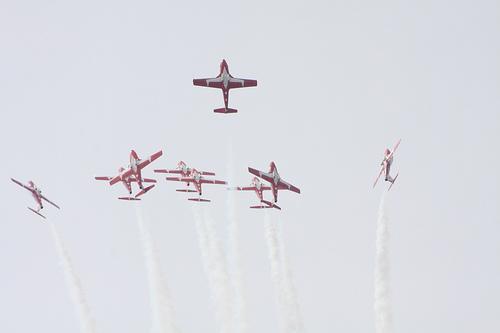How many planes have a trail of white behind them?
Give a very brief answer. 9. How many planes can you see?
Give a very brief answer. 9. How many planes?
Give a very brief answer. 9. 